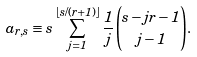Convert formula to latex. <formula><loc_0><loc_0><loc_500><loc_500>a _ { r , s } \equiv s \sum _ { j = 1 } ^ { \lfloor s / ( r + 1 ) \rfloor } \frac { 1 } { j } \binom { s - j r - 1 } { j - 1 } .</formula> 